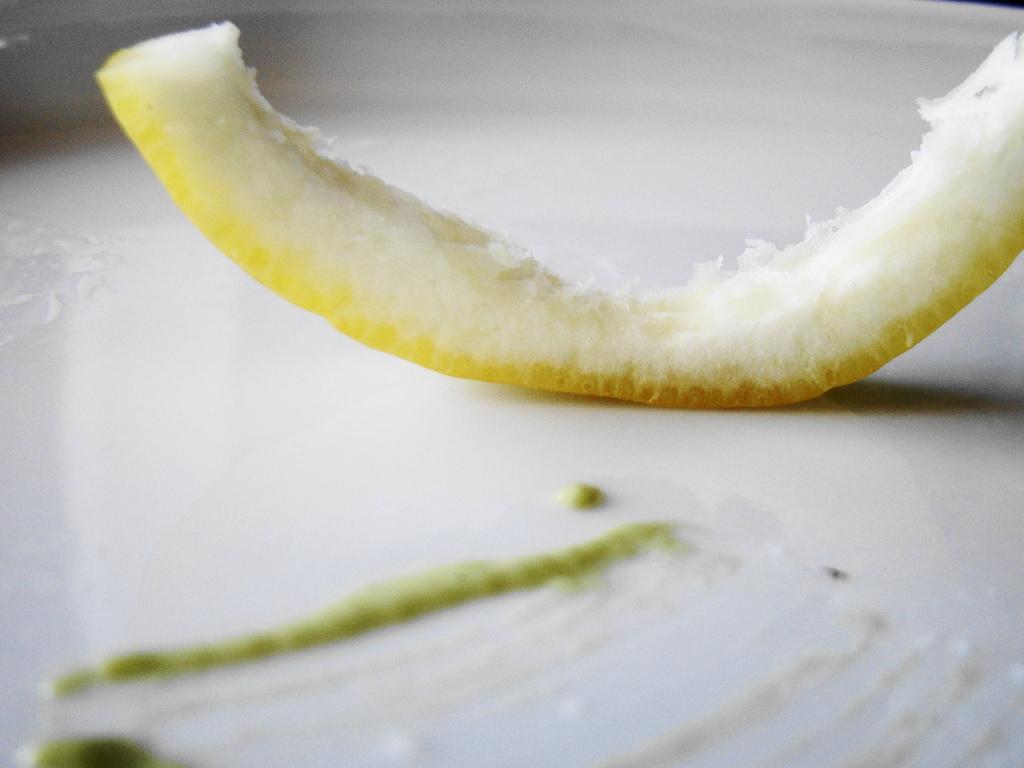Please provide a concise description of this image. In this image we can see a melon ring placed in a plate. 